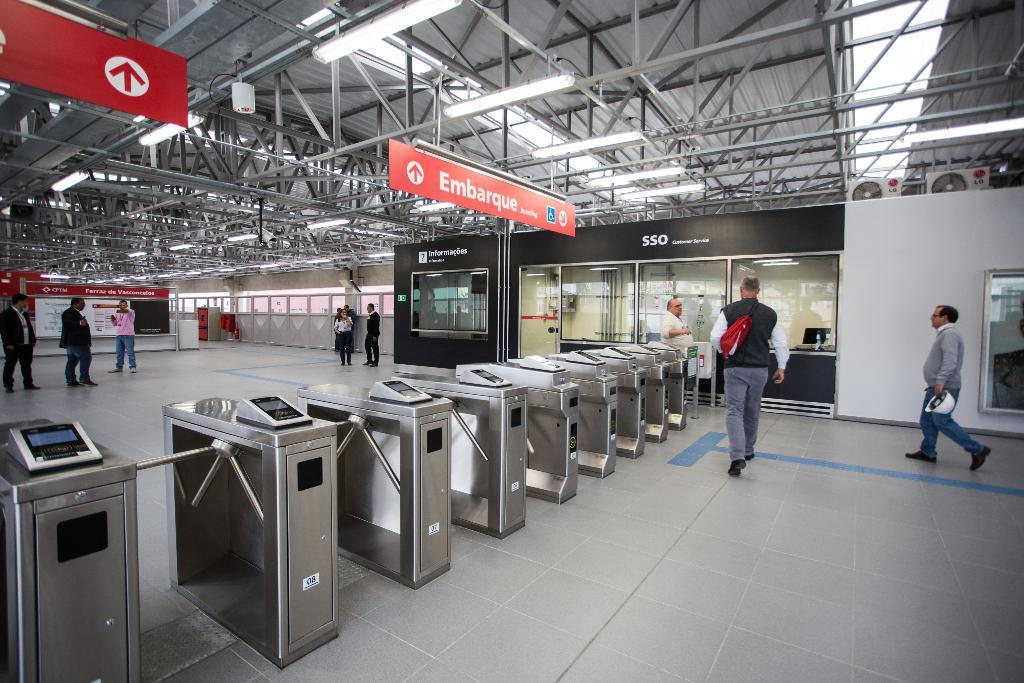<image>
Share a concise interpretation of the image provided. A row of ticket barriers which have the words Embarque over it. 